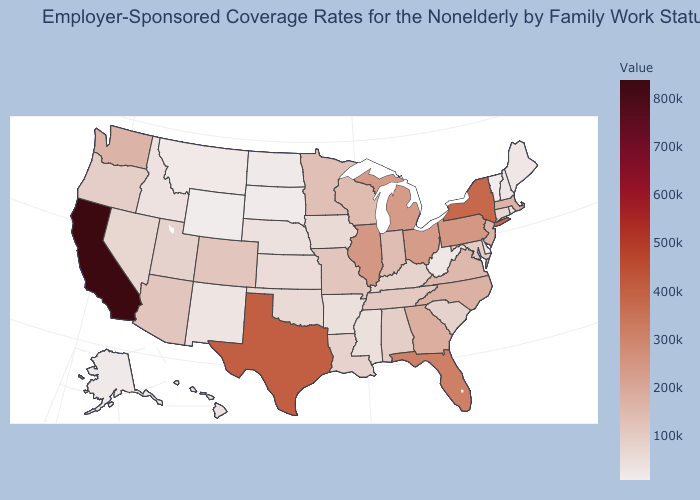Which states have the lowest value in the Northeast?
Give a very brief answer. Vermont. Does Wyoming have the lowest value in the USA?
Be succinct. Yes. Does Wyoming have the lowest value in the USA?
Write a very short answer. Yes. Which states hav the highest value in the Northeast?
Give a very brief answer. New York. Is the legend a continuous bar?
Write a very short answer. Yes. Among the states that border Vermont , does New Hampshire have the lowest value?
Keep it brief. Yes. Does Delaware have the lowest value in the South?
Short answer required. Yes. 